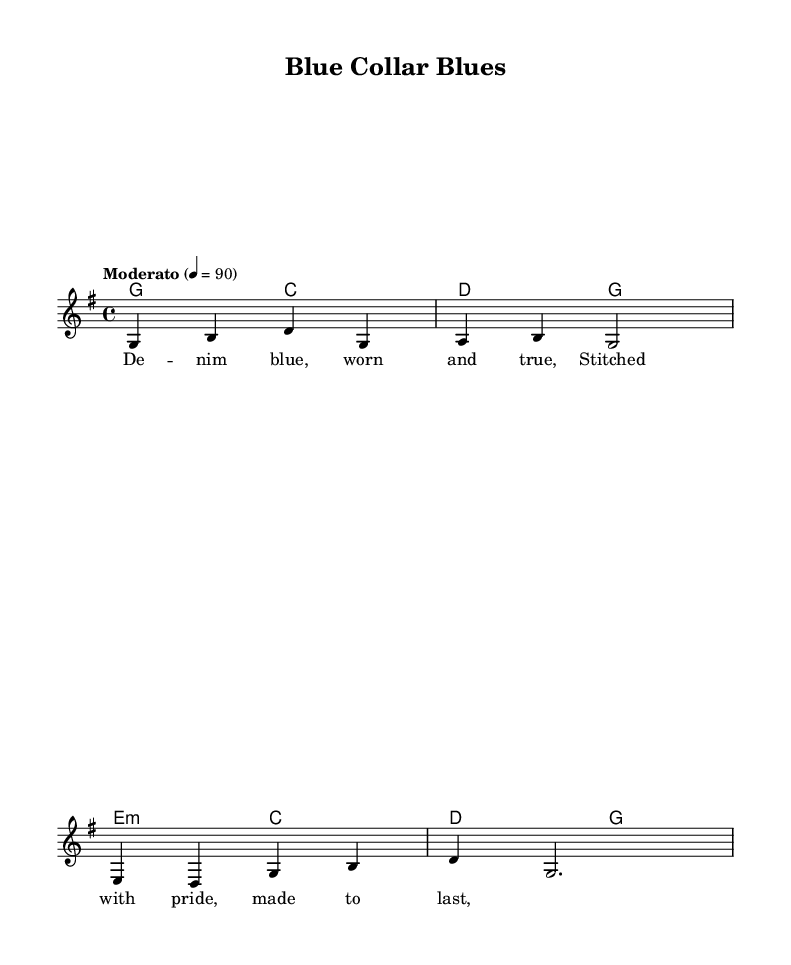What is the time signature of this music? The time signature is 4/4, indicated at the beginning of the score. This means there are four beats in each measure.
Answer: 4/4 What is the key signature of this music? The key signature is G major, which has one sharp (F#). It can be confirmed by observing the initial section of the sheet music.
Answer: G major What is the tempo marking of the music? The tempo marking is "Moderato," which suggests a moderate pace is to be followed throughout the piece. It is indicated in the tempo instruction.
Answer: Moderato How many measures are present in the melody? The melody is composed of four measures, as indicated by the separation of musical phrases and the vertical bar lines.
Answer: Four What is the name of the song represented in this sheet music? The song is titled "Blue Collar Blues," which is indicated in the header of the score.
Answer: Blue Collar Blues What type of chord is indicated in the harmonies of this piece? The harmonies include a minor chord (e minor) as indicated in the chord progression given in the score.
Answer: e minor 